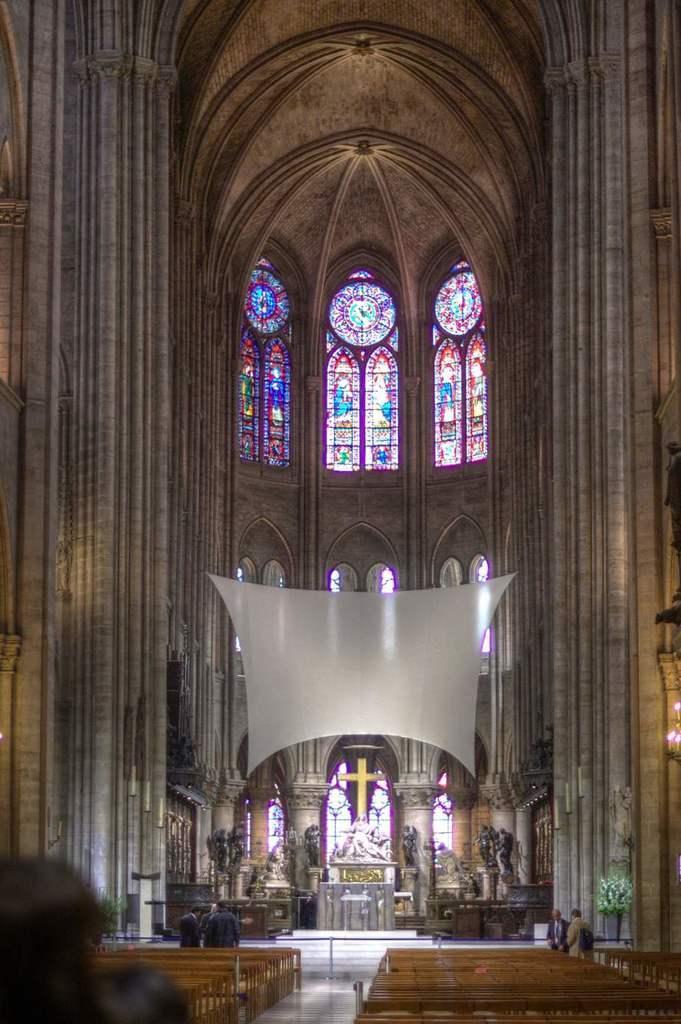Please provide a concise description of this image. In this image there are empty benches and there are persons standing, there are statues and there is a plant, there are windows and there is a wall. 